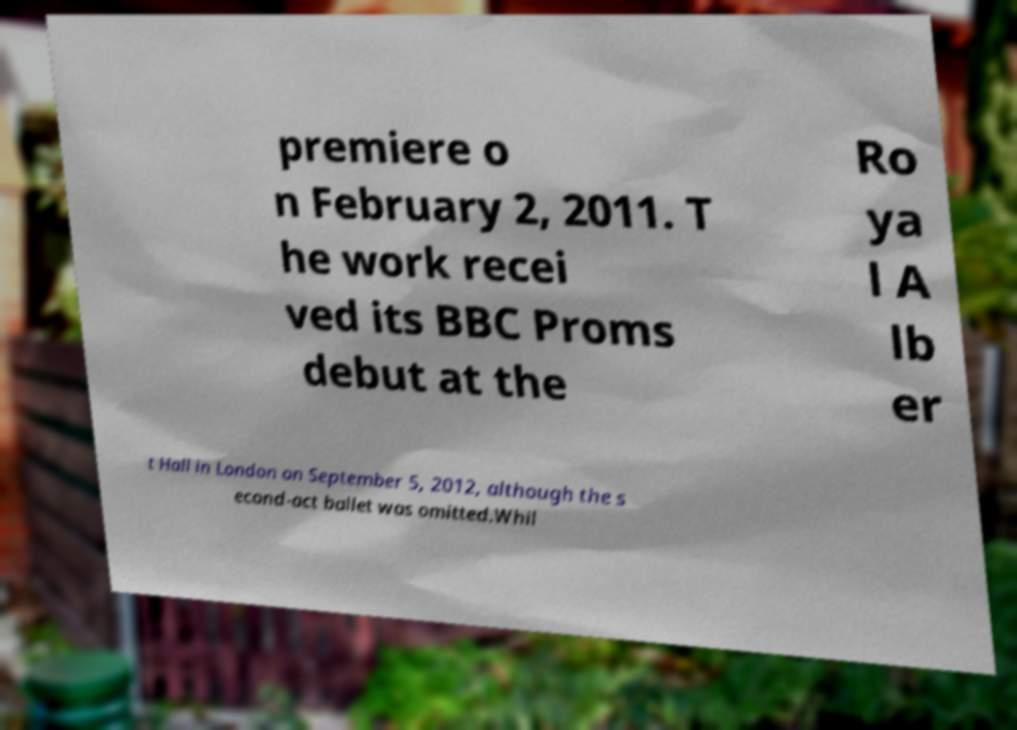For documentation purposes, I need the text within this image transcribed. Could you provide that? premiere o n February 2, 2011. T he work recei ved its BBC Proms debut at the Ro ya l A lb er t Hall in London on September 5, 2012, although the s econd-act ballet was omitted.Whil 